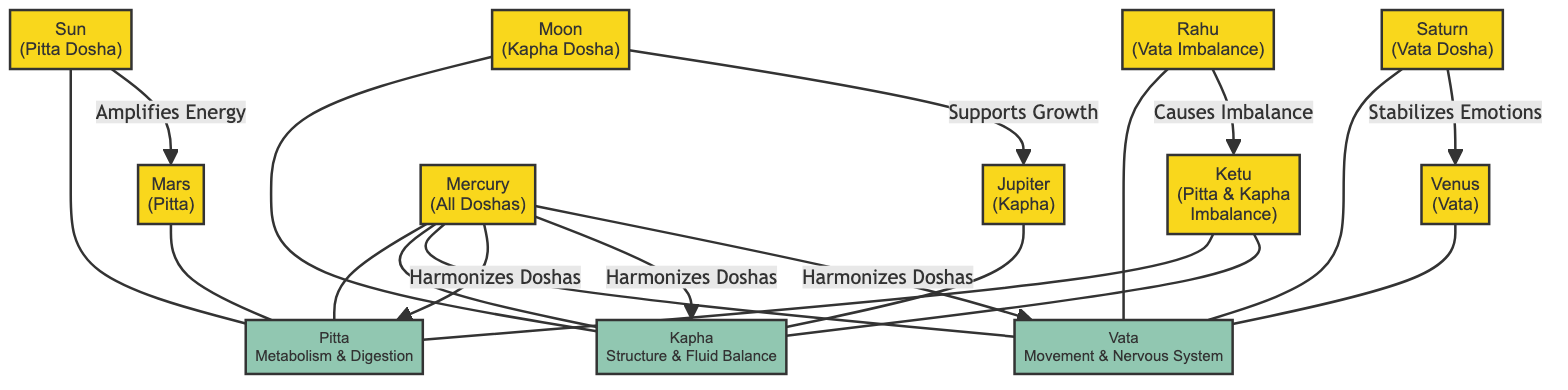What dosha is associated with the Moon? The diagram shows the Moon connected to the Kapha dosha. By identifying the connection line, we see that the Moon is explicitly labeled with "Kapha Dosha."
Answer: Kapha Dosha Which planet is linked to the Vata dosha? Looking at the diagram, Saturn and Venus are both linked to Vata dosha. By analyzing the connections, we see that Saturn is directly associated with Vata.
Answer: Saturn How many planets are associated with Pitta dosha? The diagram indicates that the Sun, Mars, and Mercury are linked to Pitta dosha. Counting these connections, we find there are three planets.
Answer: 3 What does Mercury do regarding the doshas? The diagram indicates that Mercury harmonizes all three doshas: Pitta, Kapha, and Vata. By reviewing the connections, we see these relationships clearly stated.
Answer: Harmonizes Doshas Which planet amplifies energy toward Mars? The diagram shows a direct connection from the Sun to Mars with the label "Amplifies Energy." This indicates that the Sun is responsible for amplifying energy toward Mars.
Answer: Sun What is the relationship between Rahu and Ketu? The diagram demonstrates that Rahu causes an imbalance directed towards Ketu, as evidenced by the connection labeled "Causes Imbalance." This shows a specific relational dynamic between these two planets.
Answer: Causes Imbalance How many doshas are represented in the diagram? The diagram lists three doshas: Pitta, Kapha, and Vata. By counting these distinct dosha nodes, we confirm a total of three.
Answer: 3 What effect does Saturn have on emotions? The diagram illustrates that Saturn stabilizes emotions and has a direct link to Venus. This relationship directly conveys Saturn's function regarding emotional stability.
Answer: Stabilizes Emotions Which planet supports growth towards Jupiter? By inspecting the diagram, we note that the Moon has an arrow pointing towards Jupiter labeled "Supports Growth." This indicates that the Moon plays a role in supporting growth associated with Jupiter.
Answer: Moon 